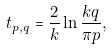<formula> <loc_0><loc_0><loc_500><loc_500>t _ { p , q } = \frac { 2 } { k } \ln \frac { k q } { \pi p } ,</formula> 